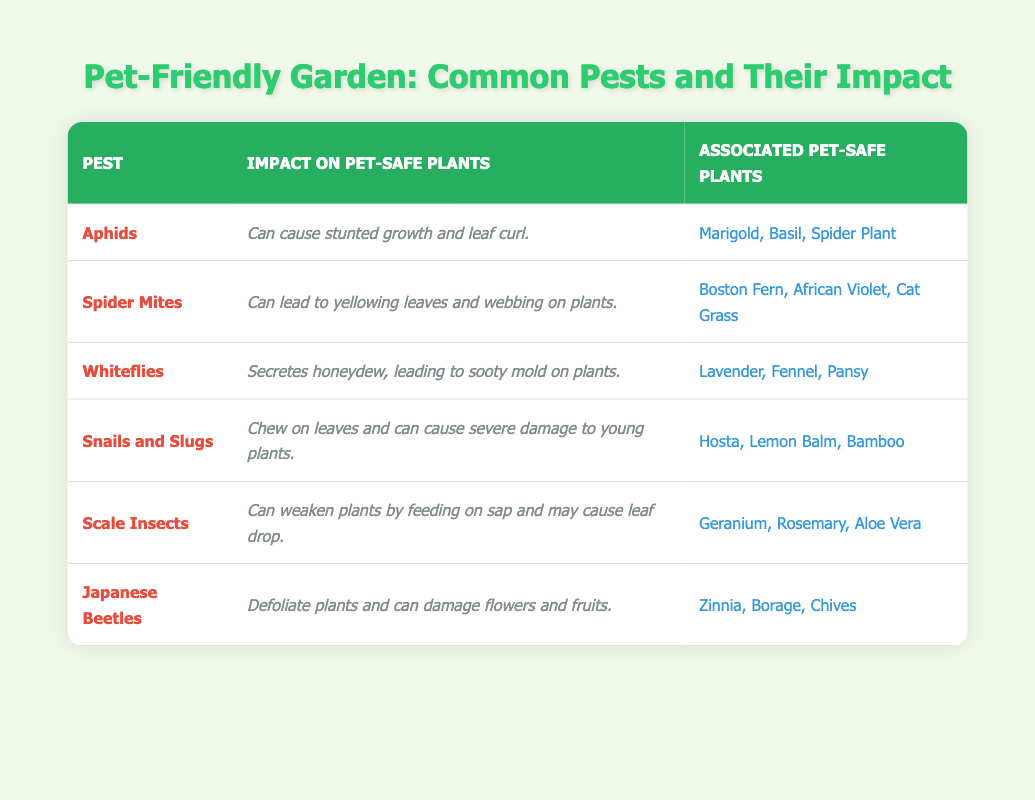What is the impact of Aphids on pet-safe plants? The table states that Aphids can cause stunted growth and leaf curl to pet-safe plants, which is directly mentioned in the corresponding row for Aphids.
Answer: Stunted growth and leaf curl Which pet-safe plants are associated with Spider Mites? The table lists the associated pet-safe plants with Spider Mites as Boston Fern, African Violet, and Cat Grass, which can be found under the row for Spider Mites.
Answer: Boston Fern, African Violet, Cat Grass Are Snails and Slugs harmful to pet-safe plants? Yes, Snails and Slugs are harmful as they chew on leaves and can cause severe damage to young plants, as noted in the impact description for Snails and Slugs in the table.
Answer: Yes How many types of pests in the table can lead to yellowing leaves? The table shows that only Spider Mites are mentioned as causing yellowing leaves, as their impact is specifically described that way. Thus, there is just one type of pest causing this effect.
Answer: 1 Do any pests secrete honeydew that affects plant growth? Yes, Whiteflies are noted to secrete honeydew, which leads to sooty mold on plants, indicating an effect on plant health, as mentioned in their row in the table.
Answer: Yes Among the listed pests, which one impacts pet-safe plants by leading to leaf drop? Scale Insects are the pests mentioned that can weaken plants by feeding on sap and may cause leaf drop, as indicated in their corresponding description in the table.
Answer: Scale Insects Which pest causes defoliation of plants? The table indicates that Japanese Beetles are responsible for defoliating plants and damaging flowers and fruits, as mentioned in the impact section for these pests.
Answer: Japanese Beetles Which two pests are associated with the most pet-safe plants, and what are those plants? Analyzing the table, both Snails and Slugs and Scale Insects are associated with three pet-safe plants each. Snails and Slugs are linked to Hosta, Lemon Balm, and Bamboo, while Scale Insects are associated with Geranium, Rosemary, and Aloe Vera.
Answer: Snails and Slugs, Scale Insects; Hosta, Lemon Balm, Bamboo; Geranium, Rosemary, Aloe Vera 